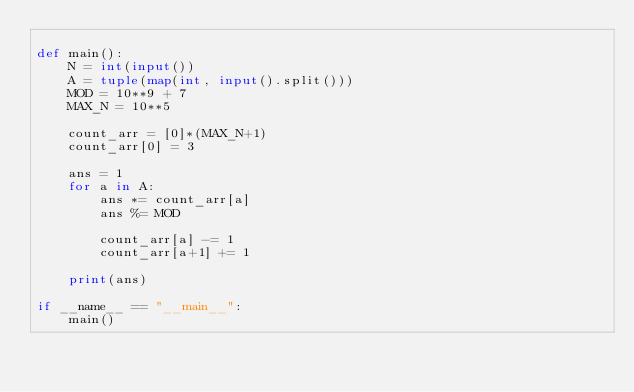Convert code to text. <code><loc_0><loc_0><loc_500><loc_500><_Python_>
def main():
    N = int(input())
    A = tuple(map(int, input().split()))
    MOD = 10**9 + 7
    MAX_N = 10**5

    count_arr = [0]*(MAX_N+1)
    count_arr[0] = 3

    ans = 1
    for a in A:
        ans *= count_arr[a]
        ans %= MOD

        count_arr[a] -= 1
        count_arr[a+1] += 1

    print(ans)

if __name__ == "__main__":
    main()</code> 